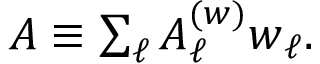Convert formula to latex. <formula><loc_0><loc_0><loc_500><loc_500>\begin{array} { r } { A \equiv \sum _ { \ell } A _ { \ell } ^ { ( w ) } w _ { \ell } . } \end{array}</formula> 